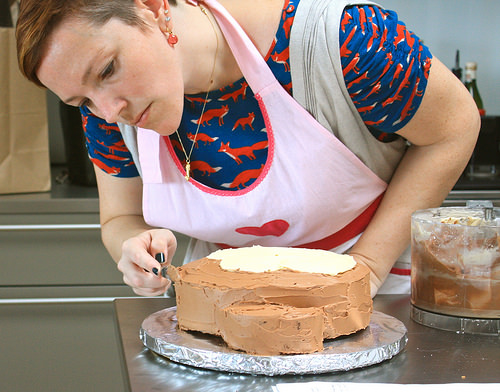<image>
Is the woman behind the cake? Yes. From this viewpoint, the woman is positioned behind the cake, with the cake partially or fully occluding the woman. Is there a cake next to the women? Yes. The cake is positioned adjacent to the women, located nearby in the same general area. 